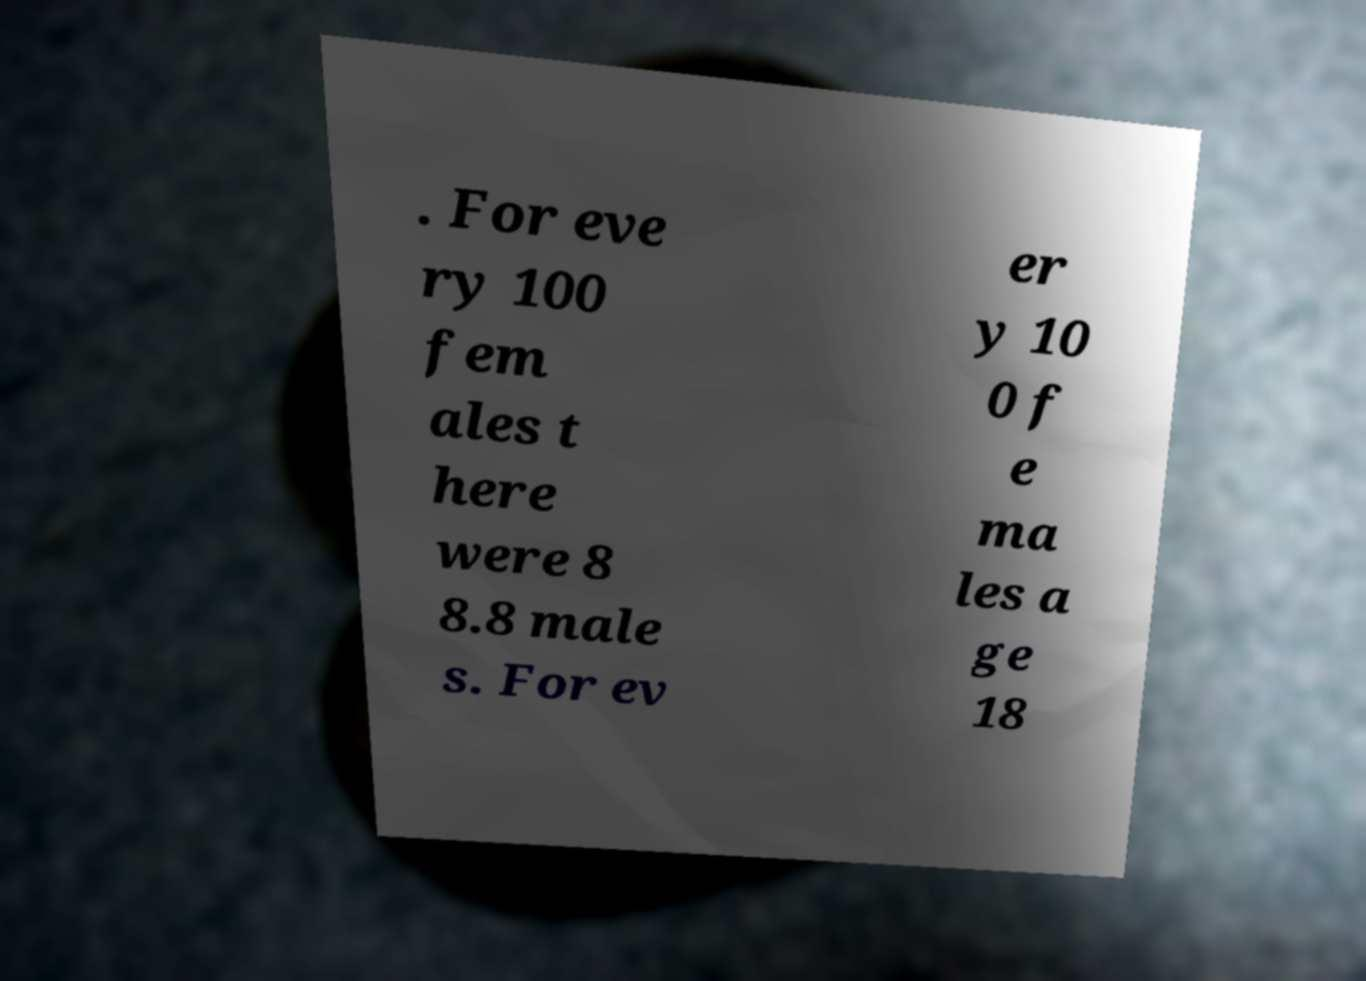There's text embedded in this image that I need extracted. Can you transcribe it verbatim? . For eve ry 100 fem ales t here were 8 8.8 male s. For ev er y 10 0 f e ma les a ge 18 